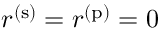<formula> <loc_0><loc_0><loc_500><loc_500>r ^ { ( s ) } = r ^ { ( p ) } = 0</formula> 